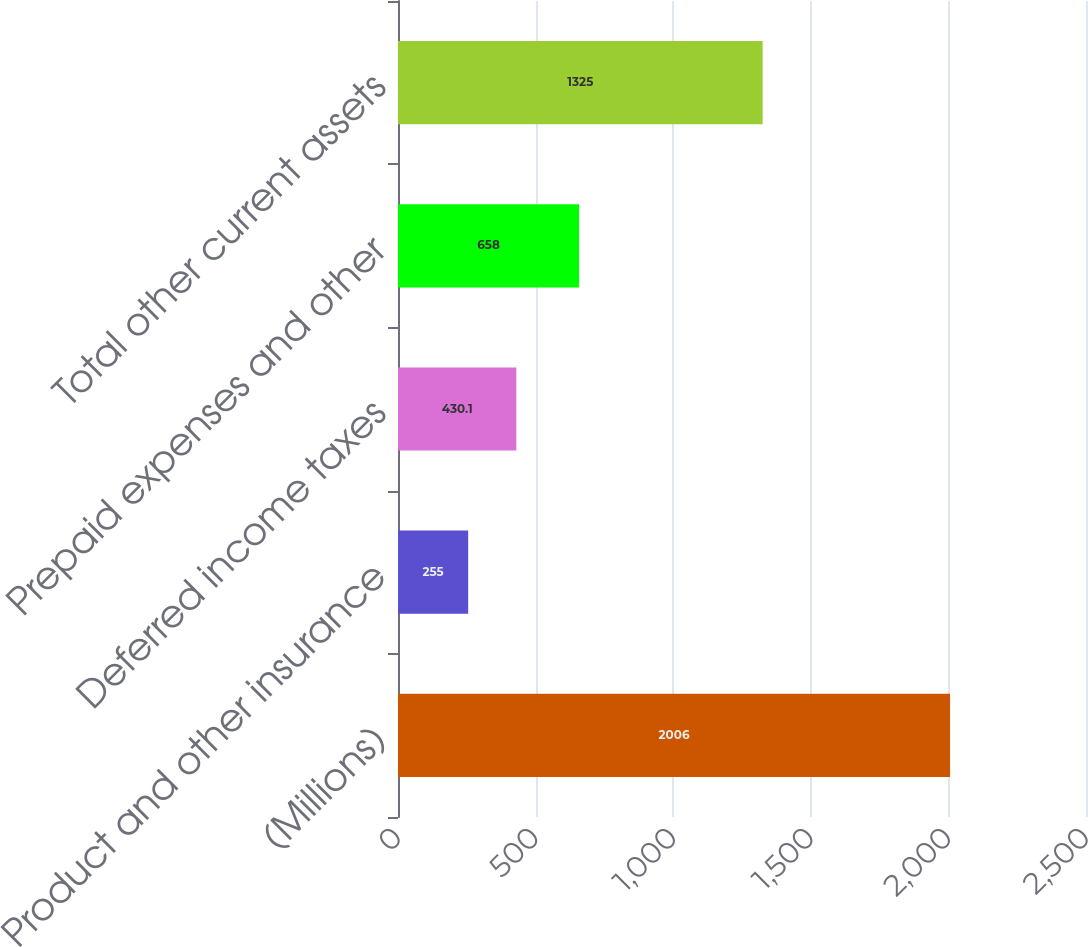<chart> <loc_0><loc_0><loc_500><loc_500><bar_chart><fcel>(Millions)<fcel>Product and other insurance<fcel>Deferred income taxes<fcel>Prepaid expenses and other<fcel>Total other current assets<nl><fcel>2006<fcel>255<fcel>430.1<fcel>658<fcel>1325<nl></chart> 